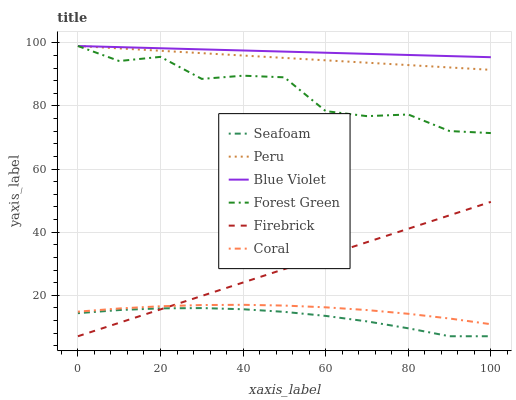Does Seafoam have the minimum area under the curve?
Answer yes or no. Yes. Does Blue Violet have the maximum area under the curve?
Answer yes or no. Yes. Does Forest Green have the minimum area under the curve?
Answer yes or no. No. Does Forest Green have the maximum area under the curve?
Answer yes or no. No. Is Firebrick the smoothest?
Answer yes or no. Yes. Is Forest Green the roughest?
Answer yes or no. Yes. Is Seafoam the smoothest?
Answer yes or no. No. Is Seafoam the roughest?
Answer yes or no. No. Does Firebrick have the lowest value?
Answer yes or no. Yes. Does Forest Green have the lowest value?
Answer yes or no. No. Does Blue Violet have the highest value?
Answer yes or no. Yes. Does Seafoam have the highest value?
Answer yes or no. No. Is Coral less than Forest Green?
Answer yes or no. Yes. Is Blue Violet greater than Seafoam?
Answer yes or no. Yes. Does Blue Violet intersect Forest Green?
Answer yes or no. Yes. Is Blue Violet less than Forest Green?
Answer yes or no. No. Is Blue Violet greater than Forest Green?
Answer yes or no. No. Does Coral intersect Forest Green?
Answer yes or no. No. 